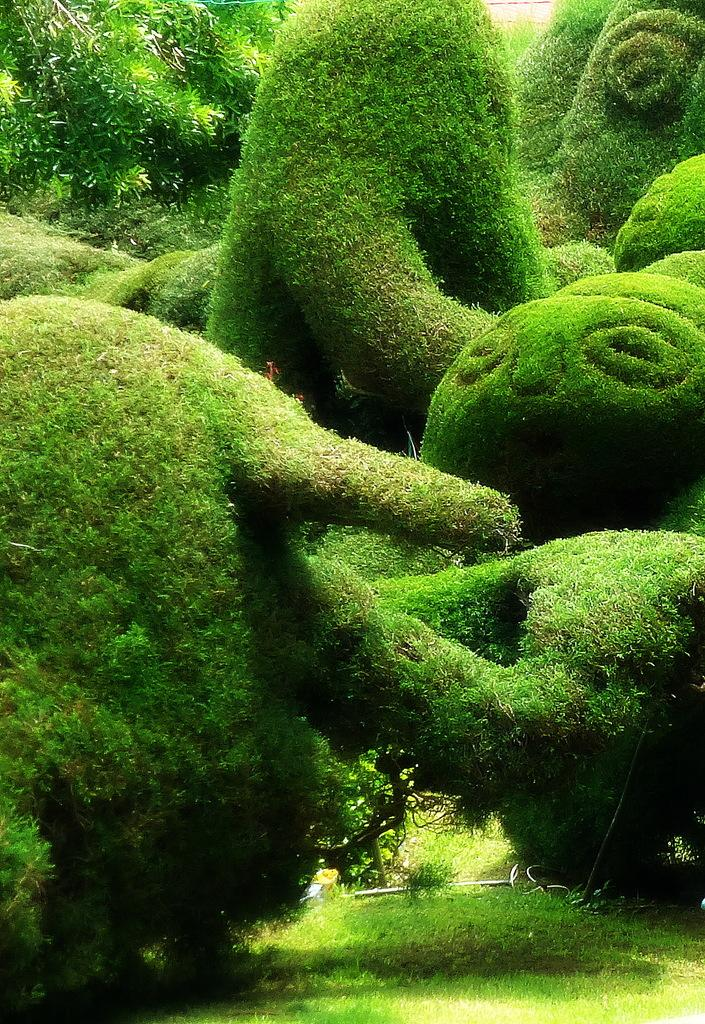What type of vegetation can be seen in the image? There are bushes in the image. How do the bushes differ from each other? The bushes have different shapes. What type of ground cover is present in the image? There is grass on the ground in the image. What color is the grandfather's sock in the image? There is no grandfather or sock present in the image. 